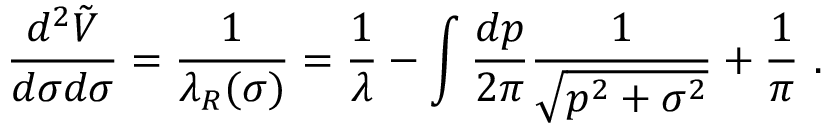Convert formula to latex. <formula><loc_0><loc_0><loc_500><loc_500>{ \frac { d ^ { 2 } \tilde { V } } { d \sigma d \sigma } } = { \frac { 1 } { \lambda _ { R } ( \sigma ) } } = { \frac { 1 } { \lambda } } - \int { \frac { d p } { 2 \pi } } { \frac { 1 } { \sqrt { p ^ { 2 } + \sigma ^ { 2 } } } } + { \frac { 1 } { \pi } } .</formula> 